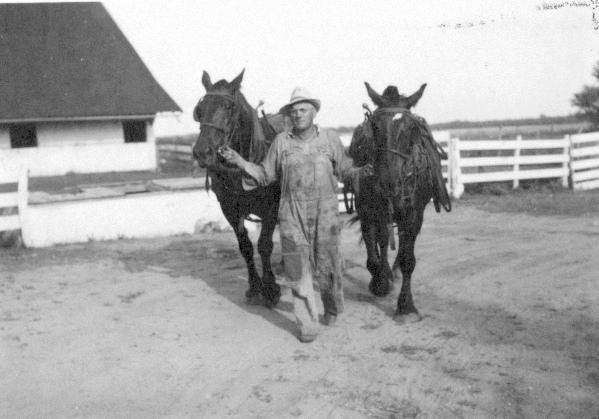How many cows are here?
Give a very brief answer. 0. How many rooftops are there?
Give a very brief answer. 1. How many legs are easily visible for the animal on the man's left?
Give a very brief answer. 2. How many people are there?
Give a very brief answer. 1. How many officers are riding horses?
Give a very brief answer. 0. How many horses are visible?
Give a very brief answer. 2. 